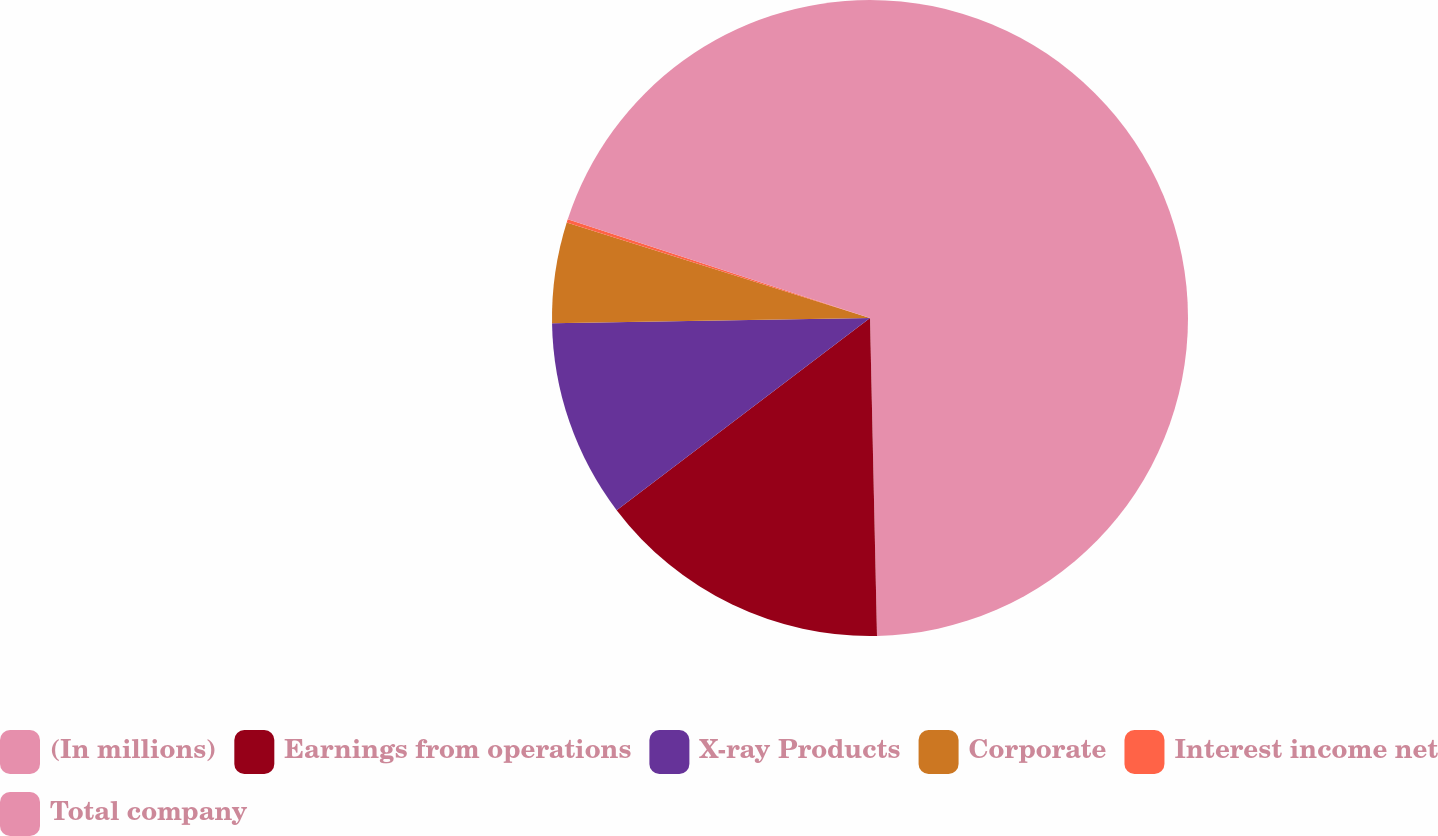<chart> <loc_0><loc_0><loc_500><loc_500><pie_chart><fcel>(In millions)<fcel>Earnings from operations<fcel>X-ray Products<fcel>Corporate<fcel>Interest income net<fcel>Total company<nl><fcel>49.65%<fcel>15.02%<fcel>10.07%<fcel>5.12%<fcel>0.17%<fcel>19.97%<nl></chart> 